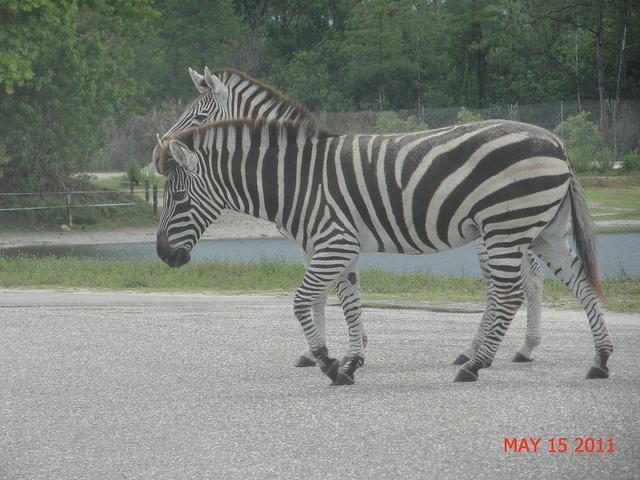How many zebras are there?
Give a very brief answer. 2. 